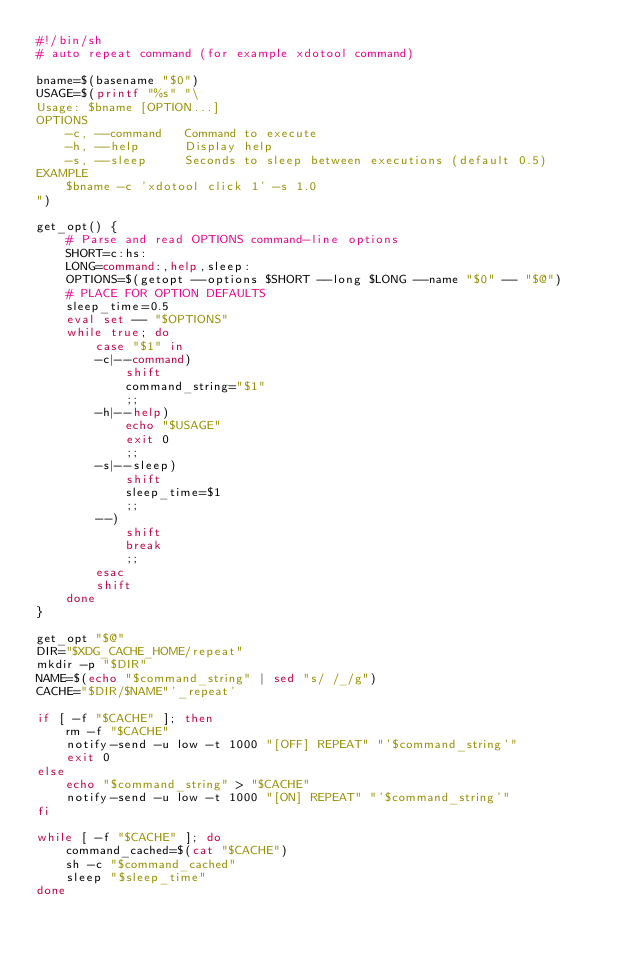Convert code to text. <code><loc_0><loc_0><loc_500><loc_500><_Bash_>#!/bin/sh
# auto repeat command (for example xdotool command)

bname=$(basename "$0")
USAGE=$(printf "%s" "\
Usage: $bname [OPTION...]
OPTIONS
    -c, --command   Command to execute
    -h, --help      Display help
    -s, --sleep     Seconds to sleep between executions (default 0.5)
EXAMPLE
    $bname -c 'xdotool click 1' -s 1.0
")

get_opt() {
    # Parse and read OPTIONS command-line options
    SHORT=c:hs:
    LONG=command:,help,sleep:
    OPTIONS=$(getopt --options $SHORT --long $LONG --name "$0" -- "$@")
    # PLACE FOR OPTION DEFAULTS
    sleep_time=0.5
    eval set -- "$OPTIONS"
    while true; do
        case "$1" in
        -c|--command)
            shift
            command_string="$1"
            ;;
        -h|--help)
            echo "$USAGE"
            exit 0
            ;;
        -s|--sleep)
            shift
            sleep_time=$1
            ;;
        --)
            shift
            break
            ;;
        esac
        shift
    done
}

get_opt "$@"
DIR="$XDG_CACHE_HOME/repeat"
mkdir -p "$DIR"
NAME=$(echo "$command_string" | sed "s/ /_/g")
CACHE="$DIR/$NAME"'_repeat'

if [ -f "$CACHE" ]; then
    rm -f "$CACHE"
    notify-send -u low -t 1000 "[OFF] REPEAT" "'$command_string'"
    exit 0
else
    echo "$command_string" > "$CACHE"
    notify-send -u low -t 1000 "[ON] REPEAT" "'$command_string'"
fi

while [ -f "$CACHE" ]; do
    command_cached=$(cat "$CACHE")
    sh -c "$command_cached"
    sleep "$sleep_time"
done

</code> 